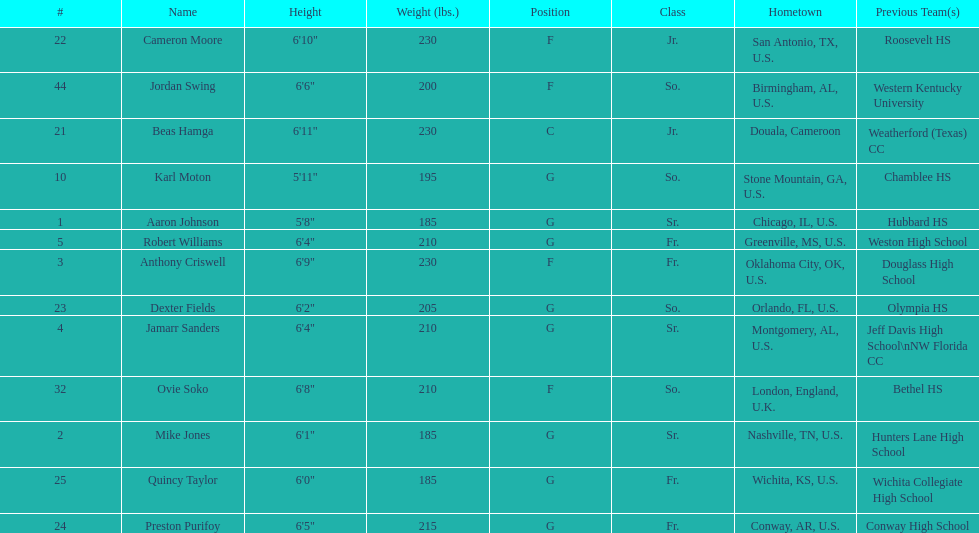Who is the tallest player on the team? Beas Hamga. 